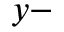Convert formula to latex. <formula><loc_0><loc_0><loc_500><loc_500>y -</formula> 